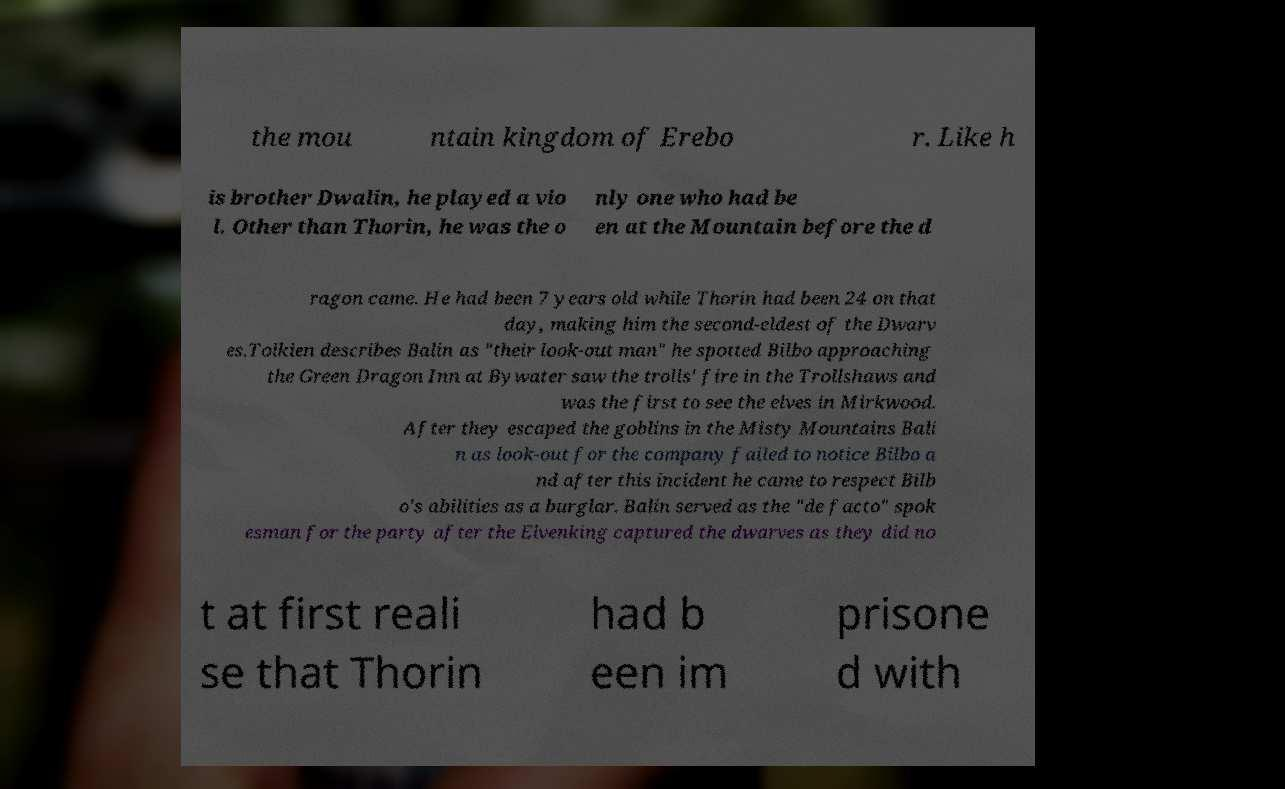For documentation purposes, I need the text within this image transcribed. Could you provide that? the mou ntain kingdom of Erebo r. Like h is brother Dwalin, he played a vio l. Other than Thorin, he was the o nly one who had be en at the Mountain before the d ragon came. He had been 7 years old while Thorin had been 24 on that day, making him the second-eldest of the Dwarv es.Tolkien describes Balin as "their look-out man" he spotted Bilbo approaching the Green Dragon Inn at Bywater saw the trolls' fire in the Trollshaws and was the first to see the elves in Mirkwood. After they escaped the goblins in the Misty Mountains Bali n as look-out for the company failed to notice Bilbo a nd after this incident he came to respect Bilb o's abilities as a burglar. Balin served as the "de facto" spok esman for the party after the Elvenking captured the dwarves as they did no t at first reali se that Thorin had b een im prisone d with 